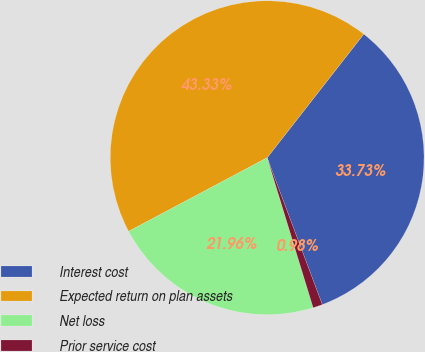Convert chart to OTSL. <chart><loc_0><loc_0><loc_500><loc_500><pie_chart><fcel>Interest cost<fcel>Expected return on plan assets<fcel>Net loss<fcel>Prior service cost<nl><fcel>33.73%<fcel>43.33%<fcel>21.96%<fcel>0.98%<nl></chart> 